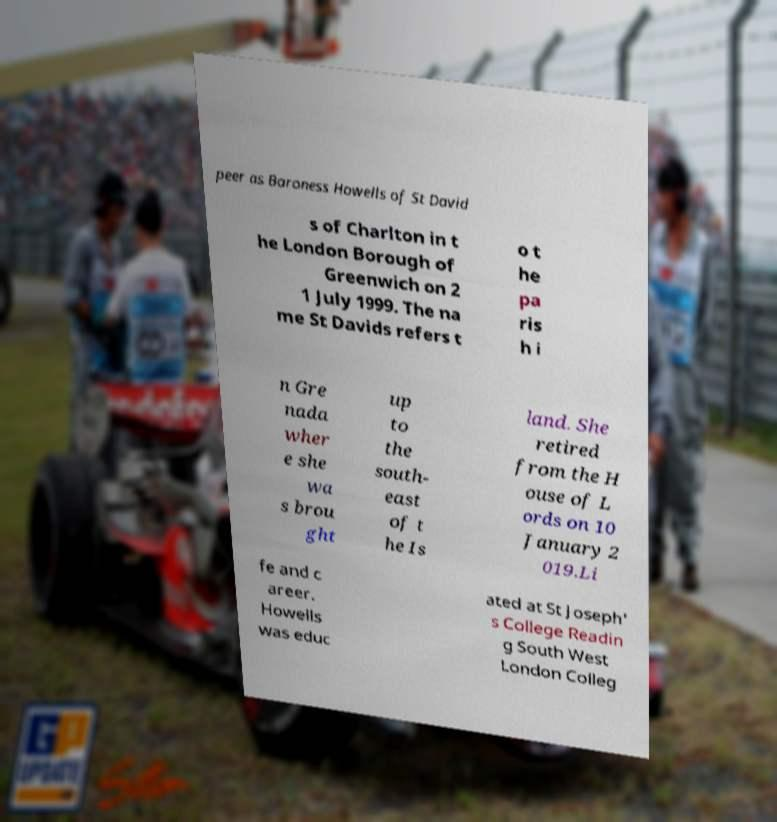I need the written content from this picture converted into text. Can you do that? peer as Baroness Howells of St David s of Charlton in t he London Borough of Greenwich on 2 1 July 1999. The na me St Davids refers t o t he pa ris h i n Gre nada wher e she wa s brou ght up to the south- east of t he Is land. She retired from the H ouse of L ords on 10 January 2 019.Li fe and c areer. Howells was educ ated at St Joseph' s College Readin g South West London Colleg 